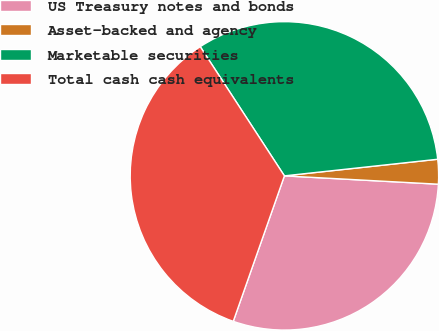Convert chart. <chart><loc_0><loc_0><loc_500><loc_500><pie_chart><fcel>US Treasury notes and bonds<fcel>Asset-backed and agency<fcel>Marketable securities<fcel>Total cash cash equivalents<nl><fcel>29.52%<fcel>2.58%<fcel>32.47%<fcel>35.43%<nl></chart> 